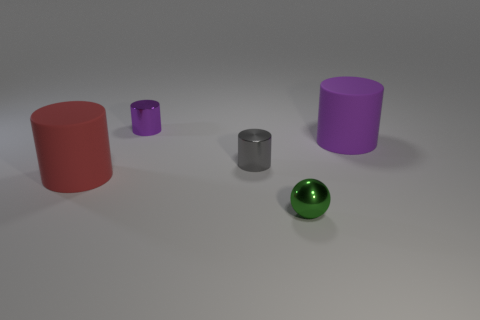Subtract 1 cylinders. How many cylinders are left? 3 Add 1 tiny gray cylinders. How many objects exist? 6 Subtract all cylinders. How many objects are left? 1 Subtract all purple rubber things. Subtract all large gray blocks. How many objects are left? 4 Add 5 big red matte cylinders. How many big red matte cylinders are left? 6 Add 3 red matte things. How many red matte things exist? 4 Subtract 0 red blocks. How many objects are left? 5 